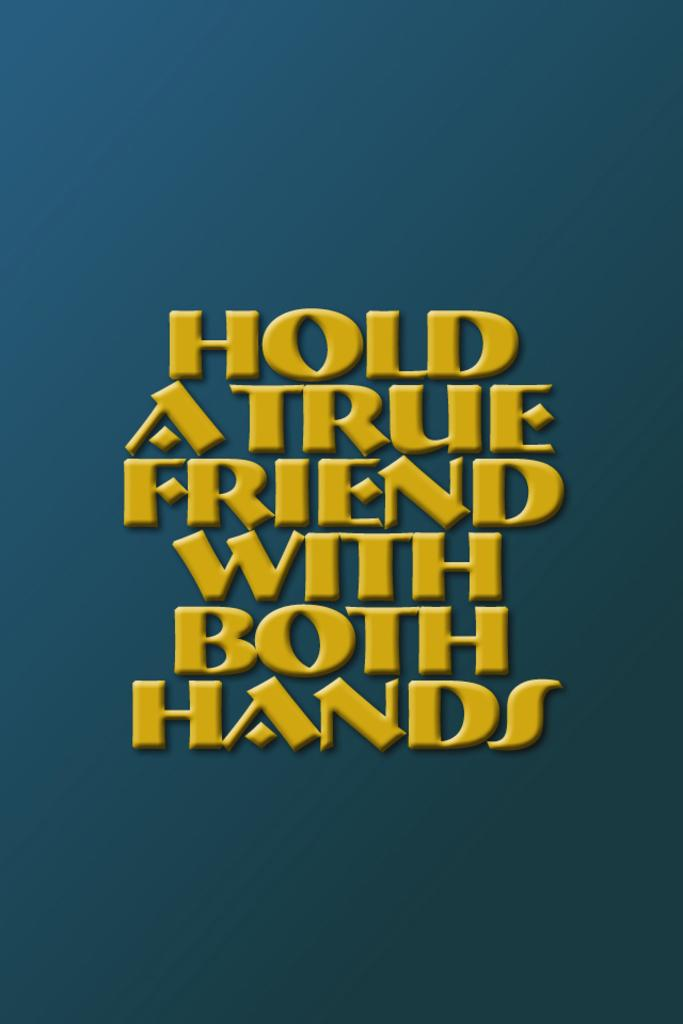<image>
Describe the image concisely. A blue background has the text "hold a true friend with both hands" in yellow lettering. 